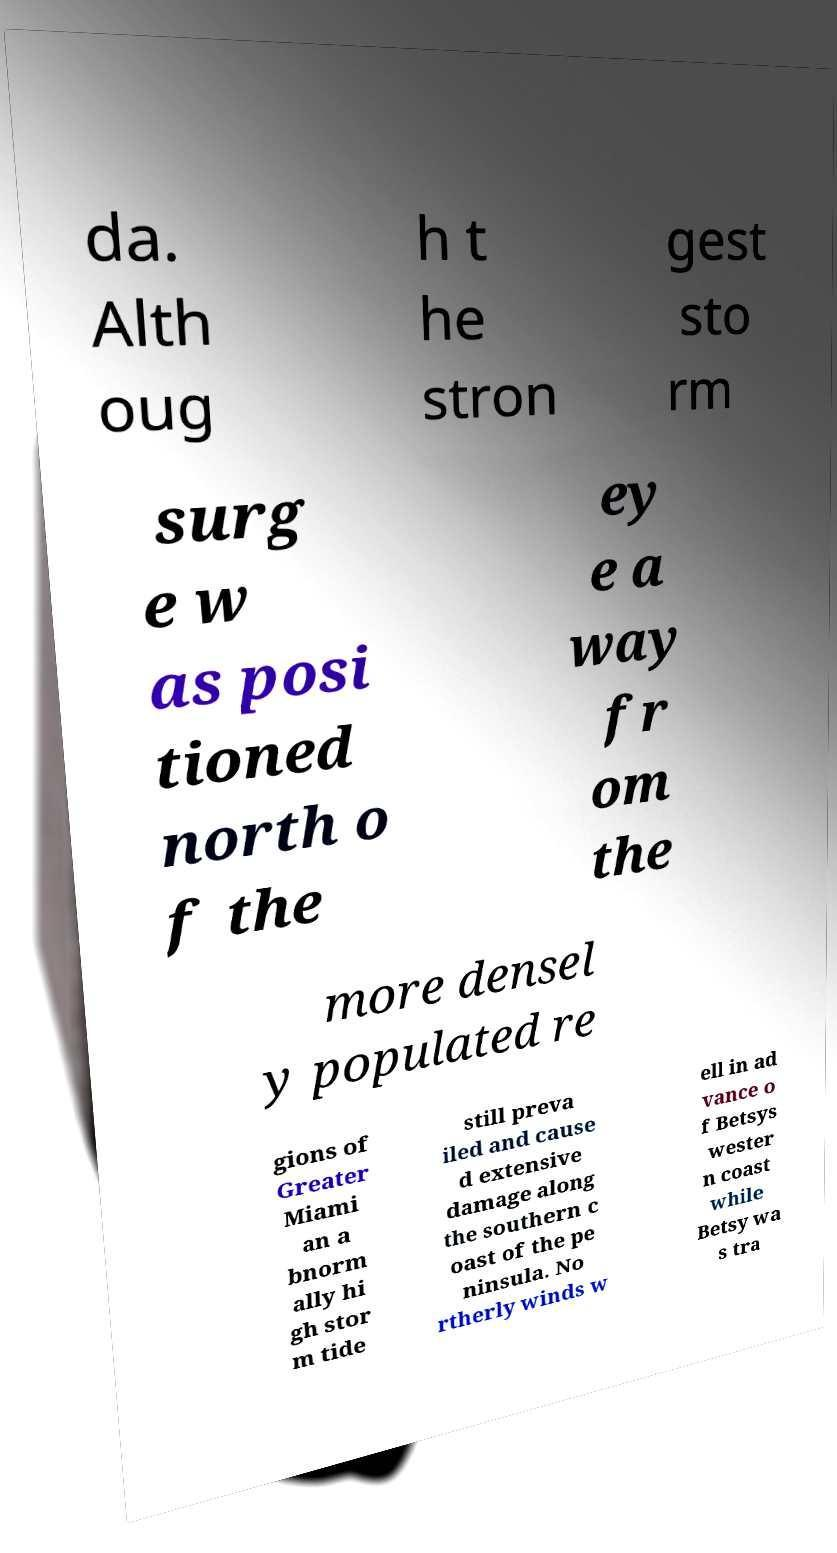Could you extract and type out the text from this image? da. Alth oug h t he stron gest sto rm surg e w as posi tioned north o f the ey e a way fr om the more densel y populated re gions of Greater Miami an a bnorm ally hi gh stor m tide still preva iled and cause d extensive damage along the southern c oast of the pe ninsula. No rtherly winds w ell in ad vance o f Betsys wester n coast while Betsy wa s tra 